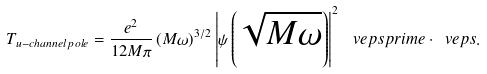<formula> <loc_0><loc_0><loc_500><loc_500>T _ { u - c h a n n e l \, p o l e } = \frac { e ^ { 2 } } { 1 2 M \pi } \, ( M \omega ) ^ { 3 / 2 } \left | \psi \left ( \sqrt { M \omega } \right ) \right | ^ { 2 } \, \ v e p s p r i m e \cdot \ v e p s .</formula> 